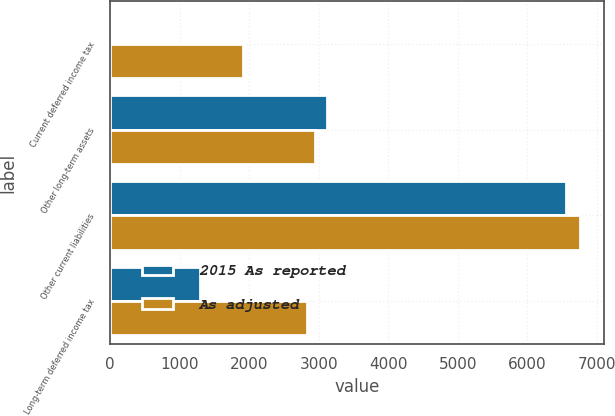Convert chart to OTSL. <chart><loc_0><loc_0><loc_500><loc_500><stacked_bar_chart><ecel><fcel>Current deferred income tax<fcel>Other long-term assets<fcel>Other current liabilities<fcel>Long-term deferred income tax<nl><fcel>2015 As reported<fcel>0<fcel>3117<fcel>6555<fcel>1295<nl><fcel>As adjusted<fcel>1915<fcel>2953<fcel>6766<fcel>2835<nl></chart> 